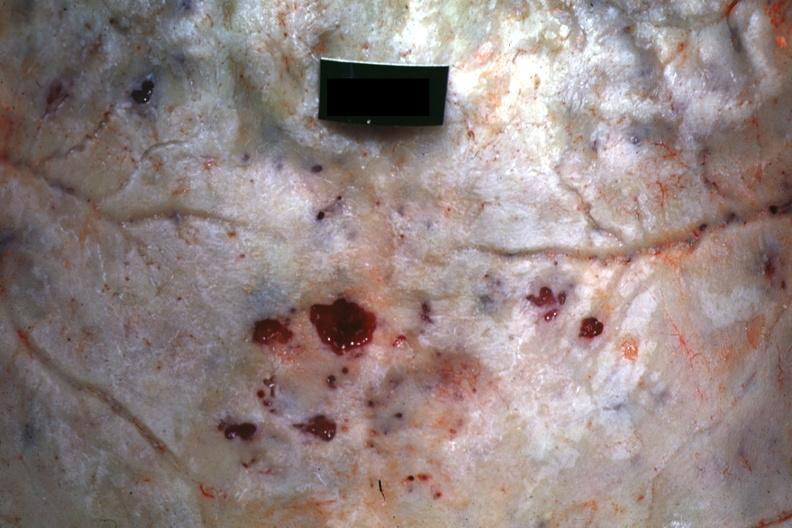s photo present?
Answer the question using a single word or phrase. No 